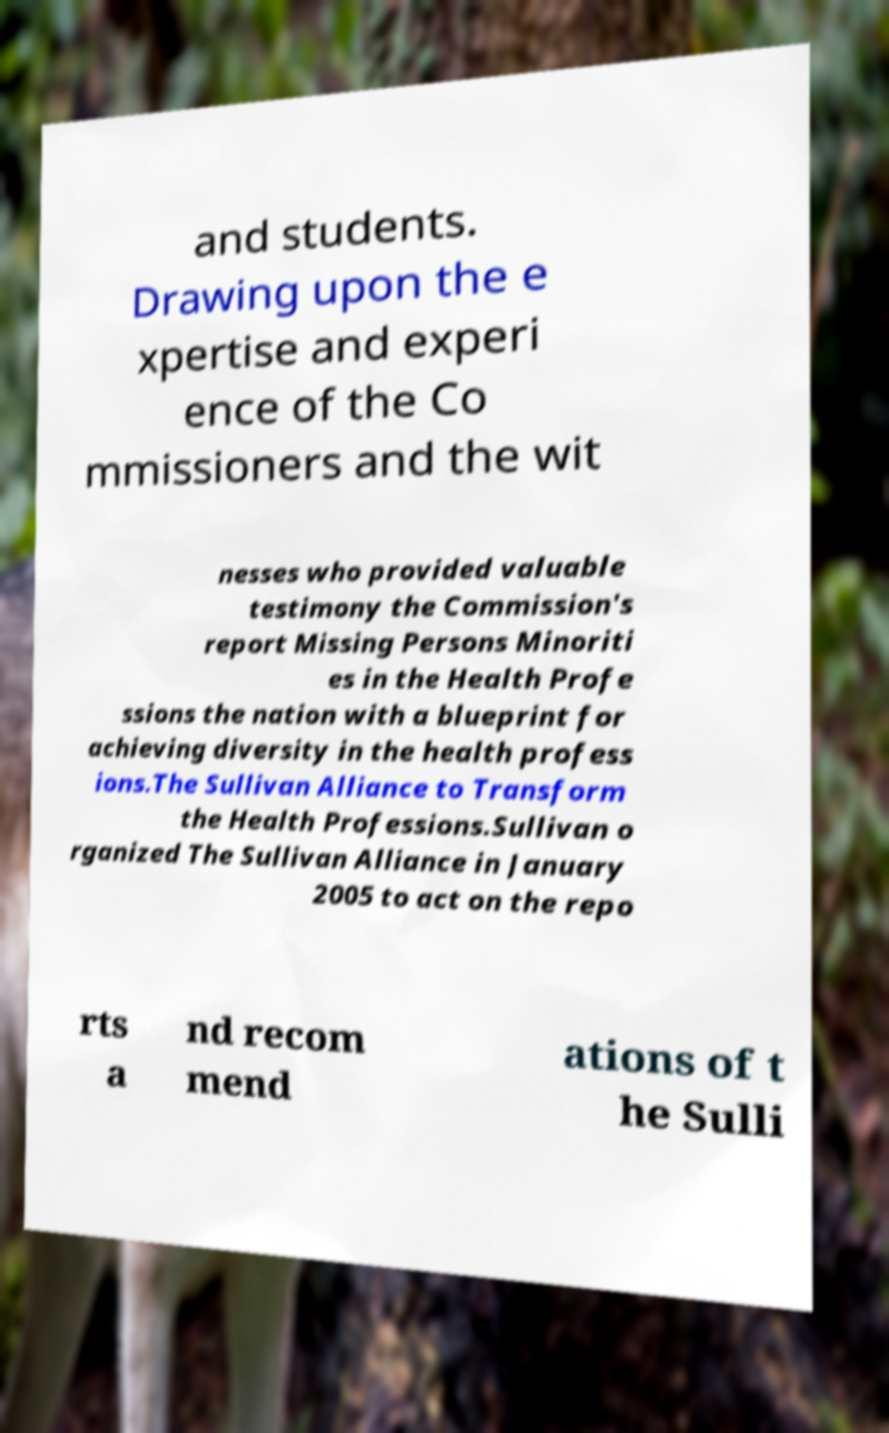Could you assist in decoding the text presented in this image and type it out clearly? and students. Drawing upon the e xpertise and experi ence of the Co mmissioners and the wit nesses who provided valuable testimony the Commission's report Missing Persons Minoriti es in the Health Profe ssions the nation with a blueprint for achieving diversity in the health profess ions.The Sullivan Alliance to Transform the Health Professions.Sullivan o rganized The Sullivan Alliance in January 2005 to act on the repo rts a nd recom mend ations of t he Sulli 